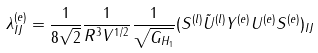Convert formula to latex. <formula><loc_0><loc_0><loc_500><loc_500>\lambda ^ { ( e ) } _ { I J } = \frac { 1 } { 8 \sqrt { 2 } } \frac { 1 } { R ^ { 3 } V ^ { 1 / 2 } } \frac { 1 } { \sqrt { G _ { H _ { 1 } } } } ( S ^ { ( l ) } { \tilde { U } ^ { ( l ) } } Y ^ { ( e ) } U ^ { ( e ) } S ^ { ( e ) } ) _ { I J }</formula> 